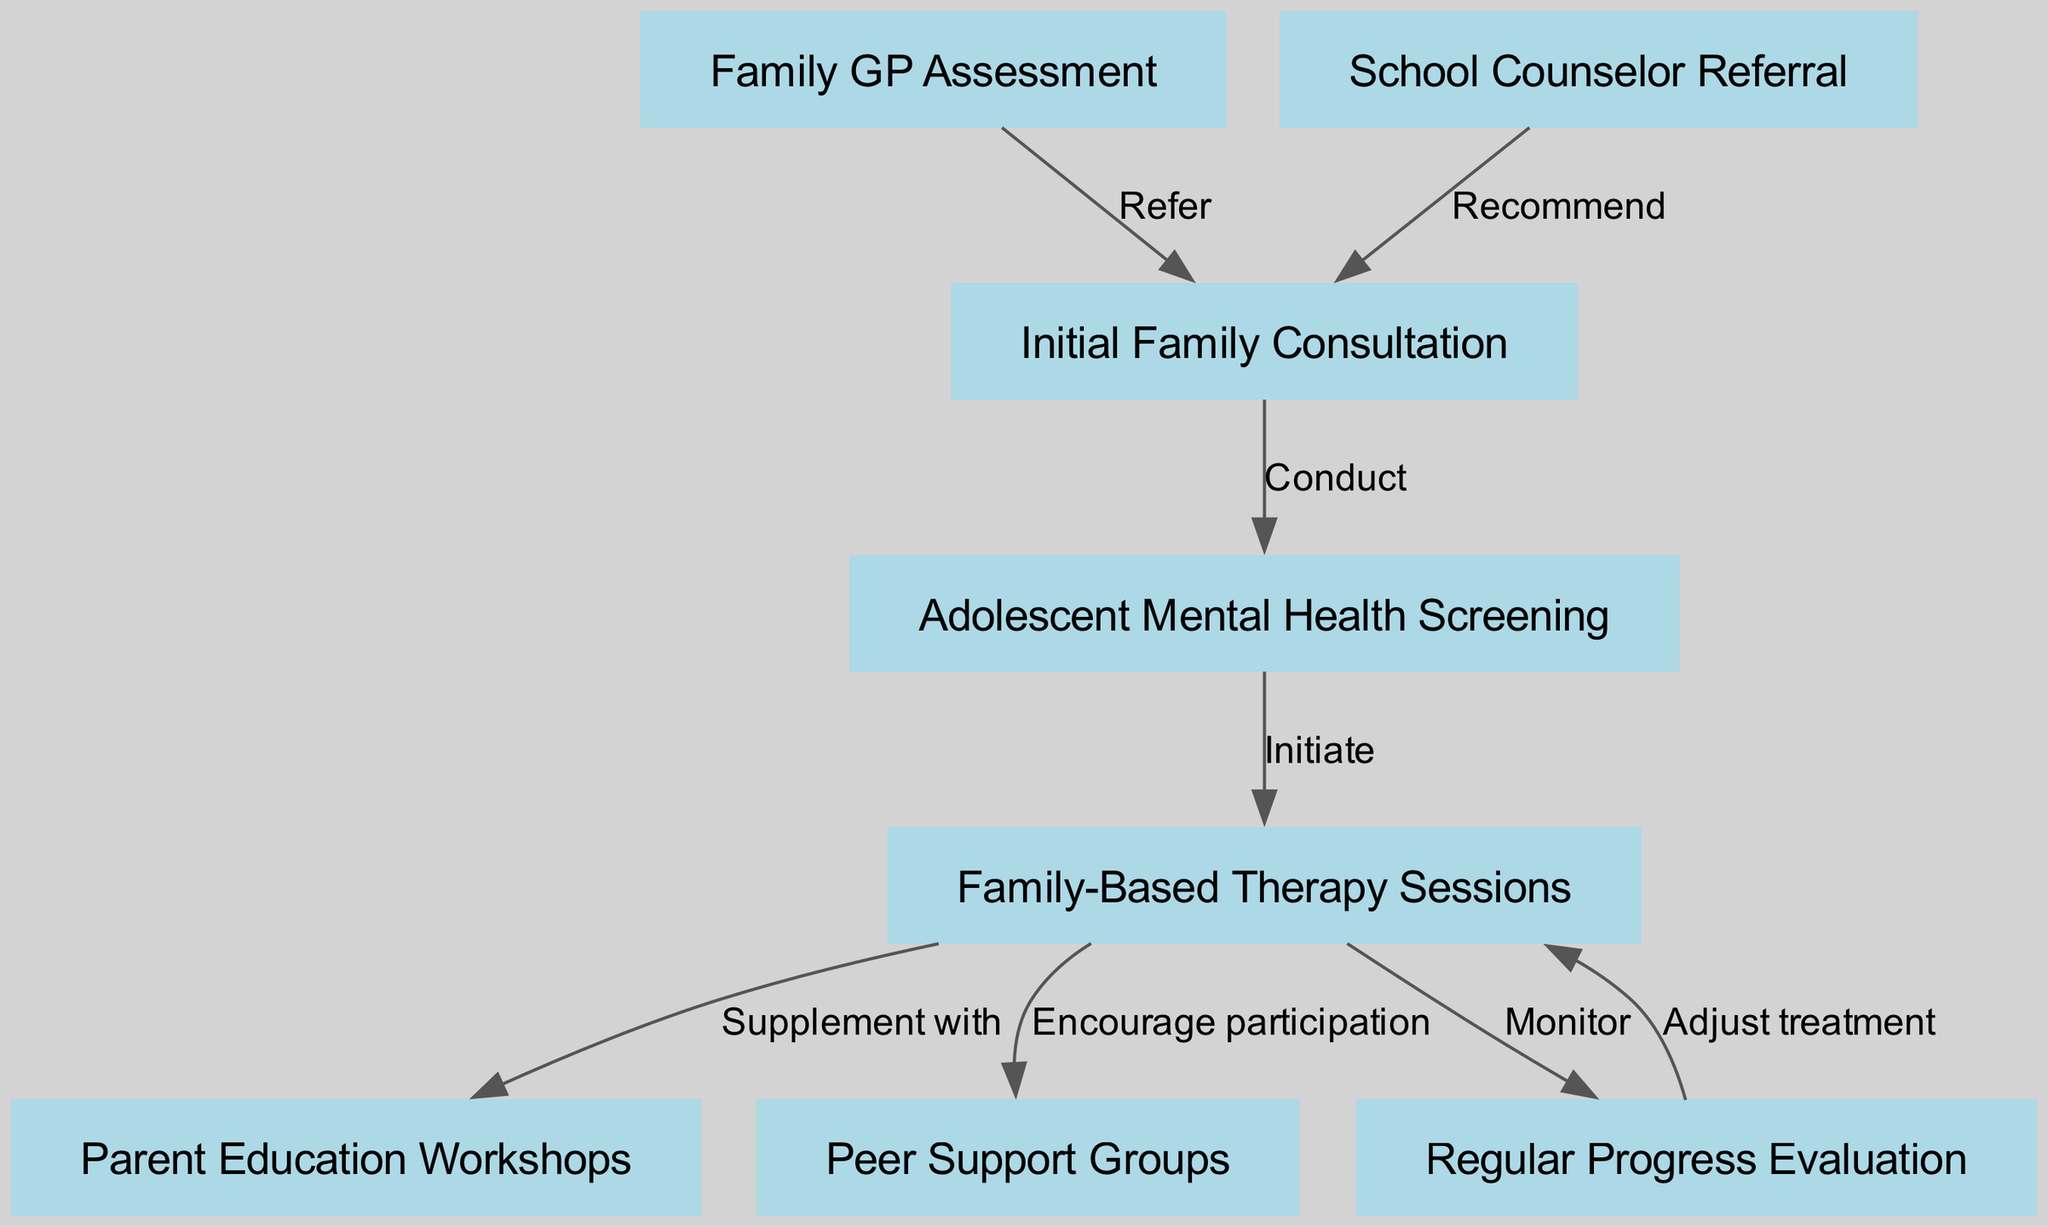What is the first step in the adolescent mental health support pathway? The first node, labeled "Family GP Assessment," indicates it is the initial step in this pathway.
Answer: Family GP Assessment How many total nodes are in the diagram? By counting the nodes listed, there are a total of eight distinct nodes representing various steps within the pathway.
Answer: 8 What action follows the "Initial Family Consultation"? The diagram shows that the action that follows is "Adolescent Mental Health Screening," which occurs immediately after the consultation node.
Answer: Adolescent Mental Health Screening Which node indicates an encouragement for social support? The "Peer Support Groups" node indicates a form of encouragement for adolescents to engage with peers for support.
Answer: Peer Support Groups What type of therapy sessions are included in the pathway? The pathway specifically mentions "Family-Based Therapy Sessions," which suggests a collaborative approach involving family members.
Answer: Family-Based Therapy Sessions Which node is followed by "Regular Progress Evaluation"? The node directly connected to "Regular Progress Evaluation" is "Family-Based Therapy Sessions," reflecting the monitoring of progress after therapy sessions.
Answer: Family-Based Therapy Sessions Which two nodes are linked by the edge labeled "Supplement with"? The nodes linked by this edge are "Family-Based Therapy Sessions" and "Parent Education Workshops," indicating a complementing relationship between therapy and education for parents.
Answer: Family-Based Therapy Sessions and Parent Education Workshops What can be adjusted based on the "Regular Progress Evaluation"? The "Family-Based Therapy Sessions" can be adjusted according to the results and insights gained from the regular evaluations of progress.
Answer: Family-Based Therapy Sessions How many edges are there connecting the nodes? Counting the edges listed in the diagram, there are a total of seven connections that detail the relationships between various steps in the pathway.
Answer: 7 